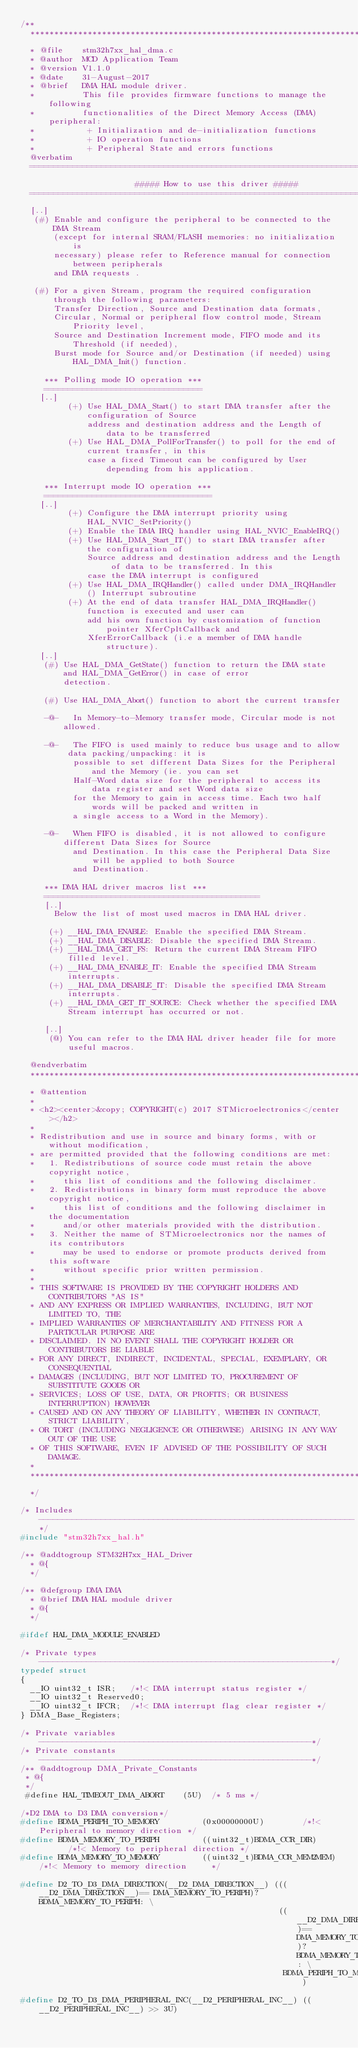<code> <loc_0><loc_0><loc_500><loc_500><_C_>/**
  ******************************************************************************
  * @file    stm32h7xx_hal_dma.c
  * @author  MCD Application Team
  * @version V1.1.0
  * @date    31-August-2017
  * @brief   DMA HAL module driver.
  *          This file provides firmware functions to manage the following
  *          functionalities of the Direct Memory Access (DMA) peripheral:
  *           + Initialization and de-initialization functions
  *           + IO operation functions
  *           + Peripheral State and errors functions
  @verbatim
  ==============================================================================
                        ##### How to use this driver #####
  ==============================================================================
  [..]
   (#) Enable and configure the peripheral to be connected to the DMA Stream
       (except for internal SRAM/FLASH memories: no initialization is
       necessary) please refer to Reference manual for connection between peripherals
       and DMA requests .

   (#) For a given Stream, program the required configuration through the following parameters:
       Transfer Direction, Source and Destination data formats,
       Circular, Normal or peripheral flow control mode, Stream Priority level,
       Source and Destination Increment mode, FIFO mode and its Threshold (if needed),
       Burst mode for Source and/or Destination (if needed) using HAL_DMA_Init() function.

     *** Polling mode IO operation ***
     =================================
    [..]
          (+) Use HAL_DMA_Start() to start DMA transfer after the configuration of Source
              address and destination address and the Length of data to be transferred
          (+) Use HAL_DMA_PollForTransfer() to poll for the end of current transfer, in this
              case a fixed Timeout can be configured by User depending from his application.

     *** Interrupt mode IO operation ***
     ===================================
    [..]
          (+) Configure the DMA interrupt priority using HAL_NVIC_SetPriority()
          (+) Enable the DMA IRQ handler using HAL_NVIC_EnableIRQ()
          (+) Use HAL_DMA_Start_IT() to start DMA transfer after the configuration of
              Source address and destination address and the Length of data to be transferred. In this
              case the DMA interrupt is configured
          (+) Use HAL_DMA_IRQHandler() called under DMA_IRQHandler() Interrupt subroutine
          (+) At the end of data transfer HAL_DMA_IRQHandler() function is executed and user can
              add his own function by customization of function pointer XferCpltCallback and
              XferErrorCallback (i.e a member of DMA handle structure).
    [..]
     (#) Use HAL_DMA_GetState() function to return the DMA state and HAL_DMA_GetError() in case of error
         detection.

     (#) Use HAL_DMA_Abort() function to abort the current transfer

     -@-   In Memory-to-Memory transfer mode, Circular mode is not allowed.

     -@-   The FIFO is used mainly to reduce bus usage and to allow data packing/unpacking: it is
           possible to set different Data Sizes for the Peripheral and the Memory (ie. you can set
           Half-Word data size for the peripheral to access its data register and set Word data size
           for the Memory to gain in access time. Each two half words will be packed and written in
           a single access to a Word in the Memory).

     -@-   When FIFO is disabled, it is not allowed to configure different Data Sizes for Source
           and Destination. In this case the Peripheral Data Size will be applied to both Source
           and Destination.

     *** DMA HAL driver macros list ***
     =============================================
     [..]
       Below the list of most used macros in DMA HAL driver.

      (+) __HAL_DMA_ENABLE: Enable the specified DMA Stream.
      (+) __HAL_DMA_DISABLE: Disable the specified DMA Stream.
      (+) __HAL_DMA_GET_FS: Return the current DMA Stream FIFO filled level.
      (+) __HAL_DMA_ENABLE_IT: Enable the specified DMA Stream interrupts.
      (+) __HAL_DMA_DISABLE_IT: Disable the specified DMA Stream interrupts.
      (+) __HAL_DMA_GET_IT_SOURCE: Check whether the specified DMA Stream interrupt has occurred or not.

     [..]
      (@) You can refer to the DMA HAL driver header file for more useful macros.

  @endverbatim
  ******************************************************************************
  * @attention
  *
  * <h2><center>&copy; COPYRIGHT(c) 2017 STMicroelectronics</center></h2>
  *
  * Redistribution and use in source and binary forms, with or without modification,
  * are permitted provided that the following conditions are met:
  *   1. Redistributions of source code must retain the above copyright notice,
  *      this list of conditions and the following disclaimer.
  *   2. Redistributions in binary form must reproduce the above copyright notice,
  *      this list of conditions and the following disclaimer in the documentation
  *      and/or other materials provided with the distribution.
  *   3. Neither the name of STMicroelectronics nor the names of its contributors
  *      may be used to endorse or promote products derived from this software
  *      without specific prior written permission.
  *
  * THIS SOFTWARE IS PROVIDED BY THE COPYRIGHT HOLDERS AND CONTRIBUTORS "AS IS"
  * AND ANY EXPRESS OR IMPLIED WARRANTIES, INCLUDING, BUT NOT LIMITED TO, THE
  * IMPLIED WARRANTIES OF MERCHANTABILITY AND FITNESS FOR A PARTICULAR PURPOSE ARE
  * DISCLAIMED. IN NO EVENT SHALL THE COPYRIGHT HOLDER OR CONTRIBUTORS BE LIABLE
  * FOR ANY DIRECT, INDIRECT, INCIDENTAL, SPECIAL, EXEMPLARY, OR CONSEQUENTIAL
  * DAMAGES (INCLUDING, BUT NOT LIMITED TO, PROCUREMENT OF SUBSTITUTE GOODS OR
  * SERVICES; LOSS OF USE, DATA, OR PROFITS; OR BUSINESS INTERRUPTION) HOWEVER
  * CAUSED AND ON ANY THEORY OF LIABILITY, WHETHER IN CONTRACT, STRICT LIABILITY,
  * OR TORT (INCLUDING NEGLIGENCE OR OTHERWISE) ARISING IN ANY WAY OUT OF THE USE
  * OF THIS SOFTWARE, EVEN IF ADVISED OF THE POSSIBILITY OF SUCH DAMAGE.
  *
  ******************************************************************************
  */

/* Includes ------------------------------------------------------------------*/
#include "stm32h7xx_hal.h"

/** @addtogroup STM32H7xx_HAL_Driver
  * @{
  */

/** @defgroup DMA DMA
  * @brief DMA HAL module driver
  * @{
  */

#ifdef HAL_DMA_MODULE_ENABLED

/* Private types -------------------------------------------------------------*/
typedef struct
{
  __IO uint32_t ISR;   /*!< DMA interrupt status register */
  __IO uint32_t Reserved0;
  __IO uint32_t IFCR;  /*!< DMA interrupt flag clear register */
} DMA_Base_Registers;

/* Private variables ---------------------------------------------------------*/
/* Private constants ---------------------------------------------------------*/
/** @addtogroup DMA_Private_Constants
 * @{
 */
 #define HAL_TIMEOUT_DMA_ABORT    (5U)  /* 5 ms */

/*D2 DMA to D3 DMA conversion*/
#define BDMA_PERIPH_TO_MEMORY         (0x00000000U)        /*!< Peripheral to memory direction */
#define BDMA_MEMORY_TO_PERIPH         ((uint32_t)BDMA_CCR_DIR)       /*!< Memory to peripheral direction */
#define BDMA_MEMORY_TO_MEMORY         ((uint32_t)BDMA_CCR_MEM2MEM) /*!< Memory to memory direction     */

#define D2_TO_D3_DMA_DIRECTION(__D2_DMA_DIRECTION__) (((__D2_DMA_DIRECTION__)== DMA_MEMORY_TO_PERIPH)? BDMA_MEMORY_TO_PERIPH: \
                                                      ((__D2_DMA_DIRECTION__)== DMA_MEMORY_TO_MEMORY)? BDMA_MEMORY_TO_MEMORY: \
                                                       BDMA_PERIPH_TO_MEMORY)

#define D2_TO_D3_DMA_PERIPHERAL_INC(__D2_PERIPHERAL_INC__) ((__D2_PERIPHERAL_INC__) >> 3U)</code> 